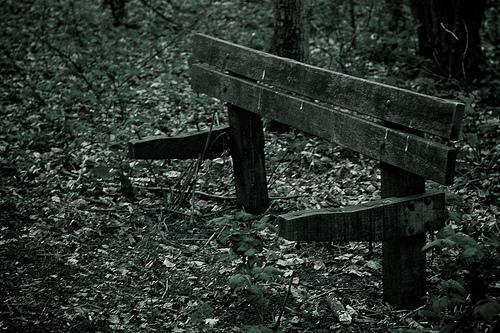How many people are wearing black pants?
Give a very brief answer. 0. 